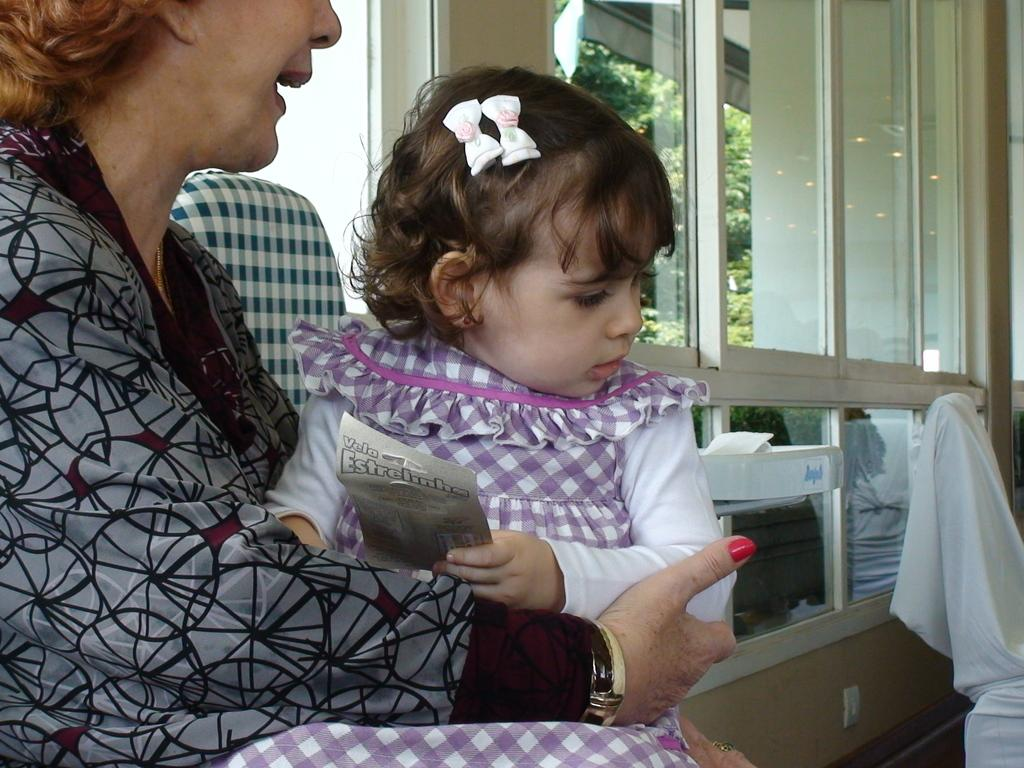What is the woman in the image doing? The woman is sitting and holding a baby in the image. Can you describe the baby in the image? The baby is described as cute. What is the woman wearing in the image? The woman is wearing a purple dress. What can be seen in the background of the image? There is a window with a glass pane in the image. What color is the paint on the drawer in the image? There is no drawer or paint present in the image. How many pickles are on the baby's head in the image? There are no pickles present in the image. 